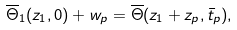Convert formula to latex. <formula><loc_0><loc_0><loc_500><loc_500>\overline { \Theta } _ { 1 } ( z _ { 1 } , 0 ) + w _ { p } = \overline { \Theta } ( z _ { 1 } + z _ { p } , \bar { t } _ { p } ) ,</formula> 